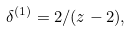<formula> <loc_0><loc_0><loc_500><loc_500>\delta ^ { ( 1 ) } = 2 / ( z - 2 ) ,</formula> 